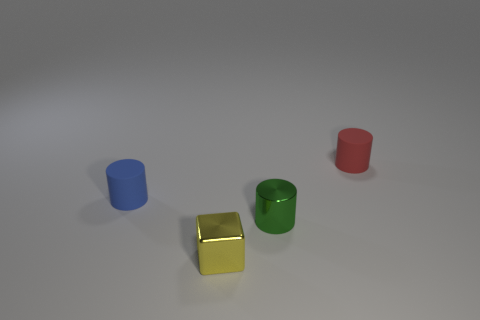Subtract all blue matte cylinders. How many cylinders are left? 2 Subtract 1 blocks. How many blocks are left? 0 Add 1 tiny yellow metallic objects. How many objects exist? 5 Subtract all cyan cylinders. Subtract all yellow blocks. How many cylinders are left? 3 Subtract all green spheres. How many blue cylinders are left? 1 Subtract all small cyan things. Subtract all tiny cylinders. How many objects are left? 1 Add 4 green shiny cylinders. How many green shiny cylinders are left? 5 Add 3 blue cylinders. How many blue cylinders exist? 4 Subtract all blue cylinders. How many cylinders are left? 2 Subtract 0 cyan cubes. How many objects are left? 4 